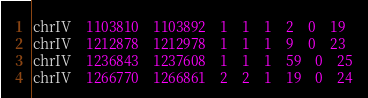<code> <loc_0><loc_0><loc_500><loc_500><_SQL_>chrIV	1103810	1103892	1	1	1	2	0	19
chrIV	1212878	1212978	1	1	1	9	0	23
chrIV	1236843	1237608	1	1	1	59	0	25
chrIV	1266770	1266861	2	2	1	19	0	24</code> 